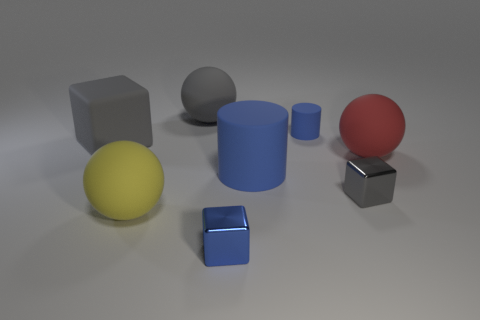Subtract all large gray matte blocks. How many blocks are left? 2 Add 1 small blue rubber cylinders. How many objects exist? 9 Subtract 2 blocks. How many blocks are left? 1 Subtract all blue blocks. How many blocks are left? 2 Subtract all cylinders. How many objects are left? 6 Subtract all cyan cylinders. How many brown spheres are left? 0 Subtract all large matte blocks. Subtract all big gray things. How many objects are left? 5 Add 6 gray matte blocks. How many gray matte blocks are left? 7 Add 1 yellow objects. How many yellow objects exist? 2 Subtract 0 green cylinders. How many objects are left? 8 